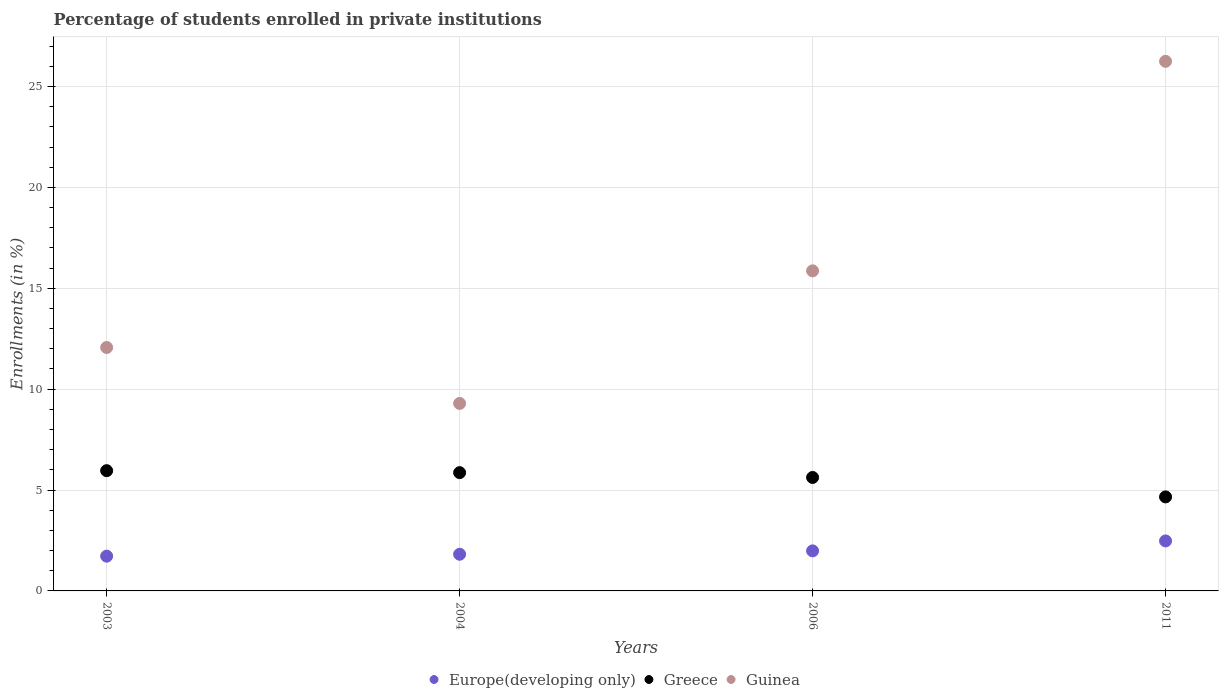What is the percentage of trained teachers in Guinea in 2011?
Give a very brief answer. 26.25. Across all years, what is the maximum percentage of trained teachers in Europe(developing only)?
Your answer should be very brief. 2.48. Across all years, what is the minimum percentage of trained teachers in Guinea?
Make the answer very short. 9.29. In which year was the percentage of trained teachers in Europe(developing only) minimum?
Offer a terse response. 2003. What is the total percentage of trained teachers in Greece in the graph?
Keep it short and to the point. 22.11. What is the difference between the percentage of trained teachers in Greece in 2004 and that in 2006?
Keep it short and to the point. 0.24. What is the difference between the percentage of trained teachers in Europe(developing only) in 2006 and the percentage of trained teachers in Greece in 2004?
Provide a short and direct response. -3.88. What is the average percentage of trained teachers in Guinea per year?
Your answer should be compact. 15.87. In the year 2011, what is the difference between the percentage of trained teachers in Guinea and percentage of trained teachers in Greece?
Offer a terse response. 21.59. In how many years, is the percentage of trained teachers in Greece greater than 18 %?
Make the answer very short. 0. What is the ratio of the percentage of trained teachers in Europe(developing only) in 2006 to that in 2011?
Make the answer very short. 0.8. Is the percentage of trained teachers in Europe(developing only) in 2003 less than that in 2011?
Offer a very short reply. Yes. Is the difference between the percentage of trained teachers in Guinea in 2003 and 2011 greater than the difference between the percentage of trained teachers in Greece in 2003 and 2011?
Your answer should be very brief. No. What is the difference between the highest and the second highest percentage of trained teachers in Europe(developing only)?
Offer a terse response. 0.49. What is the difference between the highest and the lowest percentage of trained teachers in Guinea?
Make the answer very short. 16.96. Is the sum of the percentage of trained teachers in Europe(developing only) in 2004 and 2011 greater than the maximum percentage of trained teachers in Guinea across all years?
Your answer should be very brief. No. Is it the case that in every year, the sum of the percentage of trained teachers in Guinea and percentage of trained teachers in Europe(developing only)  is greater than the percentage of trained teachers in Greece?
Keep it short and to the point. Yes. Does the percentage of trained teachers in Greece monotonically increase over the years?
Make the answer very short. No. Is the percentage of trained teachers in Europe(developing only) strictly less than the percentage of trained teachers in Greece over the years?
Your response must be concise. Yes. How many dotlines are there?
Give a very brief answer. 3. What is the difference between two consecutive major ticks on the Y-axis?
Make the answer very short. 5. Are the values on the major ticks of Y-axis written in scientific E-notation?
Offer a terse response. No. Does the graph contain any zero values?
Make the answer very short. No. Does the graph contain grids?
Offer a very short reply. Yes. How many legend labels are there?
Provide a succinct answer. 3. What is the title of the graph?
Your answer should be compact. Percentage of students enrolled in private institutions. What is the label or title of the Y-axis?
Offer a terse response. Enrollments (in %). What is the Enrollments (in %) of Europe(developing only) in 2003?
Ensure brevity in your answer.  1.72. What is the Enrollments (in %) of Greece in 2003?
Provide a succinct answer. 5.96. What is the Enrollments (in %) in Guinea in 2003?
Your answer should be very brief. 12.07. What is the Enrollments (in %) of Europe(developing only) in 2004?
Give a very brief answer. 1.82. What is the Enrollments (in %) in Greece in 2004?
Give a very brief answer. 5.86. What is the Enrollments (in %) of Guinea in 2004?
Your answer should be very brief. 9.29. What is the Enrollments (in %) of Europe(developing only) in 2006?
Offer a very short reply. 1.98. What is the Enrollments (in %) of Greece in 2006?
Keep it short and to the point. 5.62. What is the Enrollments (in %) of Guinea in 2006?
Offer a terse response. 15.86. What is the Enrollments (in %) of Europe(developing only) in 2011?
Provide a succinct answer. 2.48. What is the Enrollments (in %) in Greece in 2011?
Give a very brief answer. 4.66. What is the Enrollments (in %) in Guinea in 2011?
Your answer should be compact. 26.25. Across all years, what is the maximum Enrollments (in %) of Europe(developing only)?
Offer a terse response. 2.48. Across all years, what is the maximum Enrollments (in %) in Greece?
Your response must be concise. 5.96. Across all years, what is the maximum Enrollments (in %) of Guinea?
Your response must be concise. 26.25. Across all years, what is the minimum Enrollments (in %) in Europe(developing only)?
Your answer should be very brief. 1.72. Across all years, what is the minimum Enrollments (in %) of Greece?
Your answer should be very brief. 4.66. Across all years, what is the minimum Enrollments (in %) in Guinea?
Keep it short and to the point. 9.29. What is the total Enrollments (in %) in Europe(developing only) in the graph?
Your response must be concise. 8. What is the total Enrollments (in %) of Greece in the graph?
Your answer should be compact. 22.11. What is the total Enrollments (in %) in Guinea in the graph?
Make the answer very short. 63.48. What is the difference between the Enrollments (in %) of Europe(developing only) in 2003 and that in 2004?
Provide a short and direct response. -0.09. What is the difference between the Enrollments (in %) in Greece in 2003 and that in 2004?
Provide a short and direct response. 0.1. What is the difference between the Enrollments (in %) in Guinea in 2003 and that in 2004?
Provide a succinct answer. 2.77. What is the difference between the Enrollments (in %) in Europe(developing only) in 2003 and that in 2006?
Provide a succinct answer. -0.26. What is the difference between the Enrollments (in %) in Greece in 2003 and that in 2006?
Your response must be concise. 0.34. What is the difference between the Enrollments (in %) in Guinea in 2003 and that in 2006?
Give a very brief answer. -3.8. What is the difference between the Enrollments (in %) of Europe(developing only) in 2003 and that in 2011?
Provide a succinct answer. -0.76. What is the difference between the Enrollments (in %) in Greece in 2003 and that in 2011?
Ensure brevity in your answer.  1.3. What is the difference between the Enrollments (in %) in Guinea in 2003 and that in 2011?
Provide a succinct answer. -14.18. What is the difference between the Enrollments (in %) of Europe(developing only) in 2004 and that in 2006?
Offer a very short reply. -0.17. What is the difference between the Enrollments (in %) of Greece in 2004 and that in 2006?
Provide a succinct answer. 0.24. What is the difference between the Enrollments (in %) of Guinea in 2004 and that in 2006?
Offer a very short reply. -6.57. What is the difference between the Enrollments (in %) of Europe(developing only) in 2004 and that in 2011?
Give a very brief answer. -0.66. What is the difference between the Enrollments (in %) of Greece in 2004 and that in 2011?
Offer a terse response. 1.2. What is the difference between the Enrollments (in %) of Guinea in 2004 and that in 2011?
Offer a very short reply. -16.96. What is the difference between the Enrollments (in %) of Europe(developing only) in 2006 and that in 2011?
Keep it short and to the point. -0.49. What is the difference between the Enrollments (in %) in Greece in 2006 and that in 2011?
Your answer should be compact. 0.96. What is the difference between the Enrollments (in %) of Guinea in 2006 and that in 2011?
Make the answer very short. -10.39. What is the difference between the Enrollments (in %) of Europe(developing only) in 2003 and the Enrollments (in %) of Greece in 2004?
Provide a succinct answer. -4.14. What is the difference between the Enrollments (in %) in Europe(developing only) in 2003 and the Enrollments (in %) in Guinea in 2004?
Give a very brief answer. -7.57. What is the difference between the Enrollments (in %) in Greece in 2003 and the Enrollments (in %) in Guinea in 2004?
Keep it short and to the point. -3.33. What is the difference between the Enrollments (in %) of Europe(developing only) in 2003 and the Enrollments (in %) of Greece in 2006?
Your answer should be compact. -3.9. What is the difference between the Enrollments (in %) in Europe(developing only) in 2003 and the Enrollments (in %) in Guinea in 2006?
Your answer should be compact. -14.14. What is the difference between the Enrollments (in %) in Greece in 2003 and the Enrollments (in %) in Guinea in 2006?
Make the answer very short. -9.9. What is the difference between the Enrollments (in %) in Europe(developing only) in 2003 and the Enrollments (in %) in Greece in 2011?
Offer a terse response. -2.94. What is the difference between the Enrollments (in %) in Europe(developing only) in 2003 and the Enrollments (in %) in Guinea in 2011?
Make the answer very short. -24.53. What is the difference between the Enrollments (in %) in Greece in 2003 and the Enrollments (in %) in Guinea in 2011?
Provide a short and direct response. -20.29. What is the difference between the Enrollments (in %) of Europe(developing only) in 2004 and the Enrollments (in %) of Greece in 2006?
Offer a very short reply. -3.81. What is the difference between the Enrollments (in %) of Europe(developing only) in 2004 and the Enrollments (in %) of Guinea in 2006?
Your response must be concise. -14.05. What is the difference between the Enrollments (in %) in Greece in 2004 and the Enrollments (in %) in Guinea in 2006?
Your answer should be compact. -10. What is the difference between the Enrollments (in %) in Europe(developing only) in 2004 and the Enrollments (in %) in Greece in 2011?
Give a very brief answer. -2.84. What is the difference between the Enrollments (in %) in Europe(developing only) in 2004 and the Enrollments (in %) in Guinea in 2011?
Ensure brevity in your answer.  -24.43. What is the difference between the Enrollments (in %) in Greece in 2004 and the Enrollments (in %) in Guinea in 2011?
Your answer should be compact. -20.39. What is the difference between the Enrollments (in %) in Europe(developing only) in 2006 and the Enrollments (in %) in Greece in 2011?
Make the answer very short. -2.68. What is the difference between the Enrollments (in %) in Europe(developing only) in 2006 and the Enrollments (in %) in Guinea in 2011?
Offer a terse response. -24.27. What is the difference between the Enrollments (in %) in Greece in 2006 and the Enrollments (in %) in Guinea in 2011?
Your answer should be very brief. -20.63. What is the average Enrollments (in %) of Europe(developing only) per year?
Offer a terse response. 2. What is the average Enrollments (in %) of Greece per year?
Ensure brevity in your answer.  5.53. What is the average Enrollments (in %) of Guinea per year?
Your answer should be compact. 15.87. In the year 2003, what is the difference between the Enrollments (in %) of Europe(developing only) and Enrollments (in %) of Greece?
Ensure brevity in your answer.  -4.24. In the year 2003, what is the difference between the Enrollments (in %) in Europe(developing only) and Enrollments (in %) in Guinea?
Your answer should be very brief. -10.34. In the year 2003, what is the difference between the Enrollments (in %) in Greece and Enrollments (in %) in Guinea?
Your response must be concise. -6.11. In the year 2004, what is the difference between the Enrollments (in %) in Europe(developing only) and Enrollments (in %) in Greece?
Your answer should be very brief. -4.04. In the year 2004, what is the difference between the Enrollments (in %) in Europe(developing only) and Enrollments (in %) in Guinea?
Offer a very short reply. -7.48. In the year 2004, what is the difference between the Enrollments (in %) of Greece and Enrollments (in %) of Guinea?
Ensure brevity in your answer.  -3.43. In the year 2006, what is the difference between the Enrollments (in %) of Europe(developing only) and Enrollments (in %) of Greece?
Ensure brevity in your answer.  -3.64. In the year 2006, what is the difference between the Enrollments (in %) in Europe(developing only) and Enrollments (in %) in Guinea?
Give a very brief answer. -13.88. In the year 2006, what is the difference between the Enrollments (in %) of Greece and Enrollments (in %) of Guinea?
Offer a terse response. -10.24. In the year 2011, what is the difference between the Enrollments (in %) in Europe(developing only) and Enrollments (in %) in Greece?
Your answer should be compact. -2.18. In the year 2011, what is the difference between the Enrollments (in %) of Europe(developing only) and Enrollments (in %) of Guinea?
Offer a terse response. -23.77. In the year 2011, what is the difference between the Enrollments (in %) in Greece and Enrollments (in %) in Guinea?
Your answer should be compact. -21.59. What is the ratio of the Enrollments (in %) in Europe(developing only) in 2003 to that in 2004?
Keep it short and to the point. 0.95. What is the ratio of the Enrollments (in %) in Greece in 2003 to that in 2004?
Your response must be concise. 1.02. What is the ratio of the Enrollments (in %) in Guinea in 2003 to that in 2004?
Make the answer very short. 1.3. What is the ratio of the Enrollments (in %) in Europe(developing only) in 2003 to that in 2006?
Ensure brevity in your answer.  0.87. What is the ratio of the Enrollments (in %) in Greece in 2003 to that in 2006?
Your answer should be very brief. 1.06. What is the ratio of the Enrollments (in %) of Guinea in 2003 to that in 2006?
Give a very brief answer. 0.76. What is the ratio of the Enrollments (in %) of Europe(developing only) in 2003 to that in 2011?
Offer a very short reply. 0.7. What is the ratio of the Enrollments (in %) in Greece in 2003 to that in 2011?
Keep it short and to the point. 1.28. What is the ratio of the Enrollments (in %) of Guinea in 2003 to that in 2011?
Keep it short and to the point. 0.46. What is the ratio of the Enrollments (in %) in Europe(developing only) in 2004 to that in 2006?
Provide a short and direct response. 0.92. What is the ratio of the Enrollments (in %) in Greece in 2004 to that in 2006?
Your answer should be very brief. 1.04. What is the ratio of the Enrollments (in %) in Guinea in 2004 to that in 2006?
Your answer should be compact. 0.59. What is the ratio of the Enrollments (in %) of Europe(developing only) in 2004 to that in 2011?
Ensure brevity in your answer.  0.73. What is the ratio of the Enrollments (in %) of Greece in 2004 to that in 2011?
Your answer should be compact. 1.26. What is the ratio of the Enrollments (in %) of Guinea in 2004 to that in 2011?
Your answer should be compact. 0.35. What is the ratio of the Enrollments (in %) in Europe(developing only) in 2006 to that in 2011?
Provide a short and direct response. 0.8. What is the ratio of the Enrollments (in %) of Greece in 2006 to that in 2011?
Keep it short and to the point. 1.21. What is the ratio of the Enrollments (in %) in Guinea in 2006 to that in 2011?
Give a very brief answer. 0.6. What is the difference between the highest and the second highest Enrollments (in %) of Europe(developing only)?
Provide a succinct answer. 0.49. What is the difference between the highest and the second highest Enrollments (in %) of Greece?
Offer a very short reply. 0.1. What is the difference between the highest and the second highest Enrollments (in %) of Guinea?
Your answer should be compact. 10.39. What is the difference between the highest and the lowest Enrollments (in %) of Europe(developing only)?
Your answer should be compact. 0.76. What is the difference between the highest and the lowest Enrollments (in %) of Greece?
Provide a succinct answer. 1.3. What is the difference between the highest and the lowest Enrollments (in %) in Guinea?
Your answer should be very brief. 16.96. 